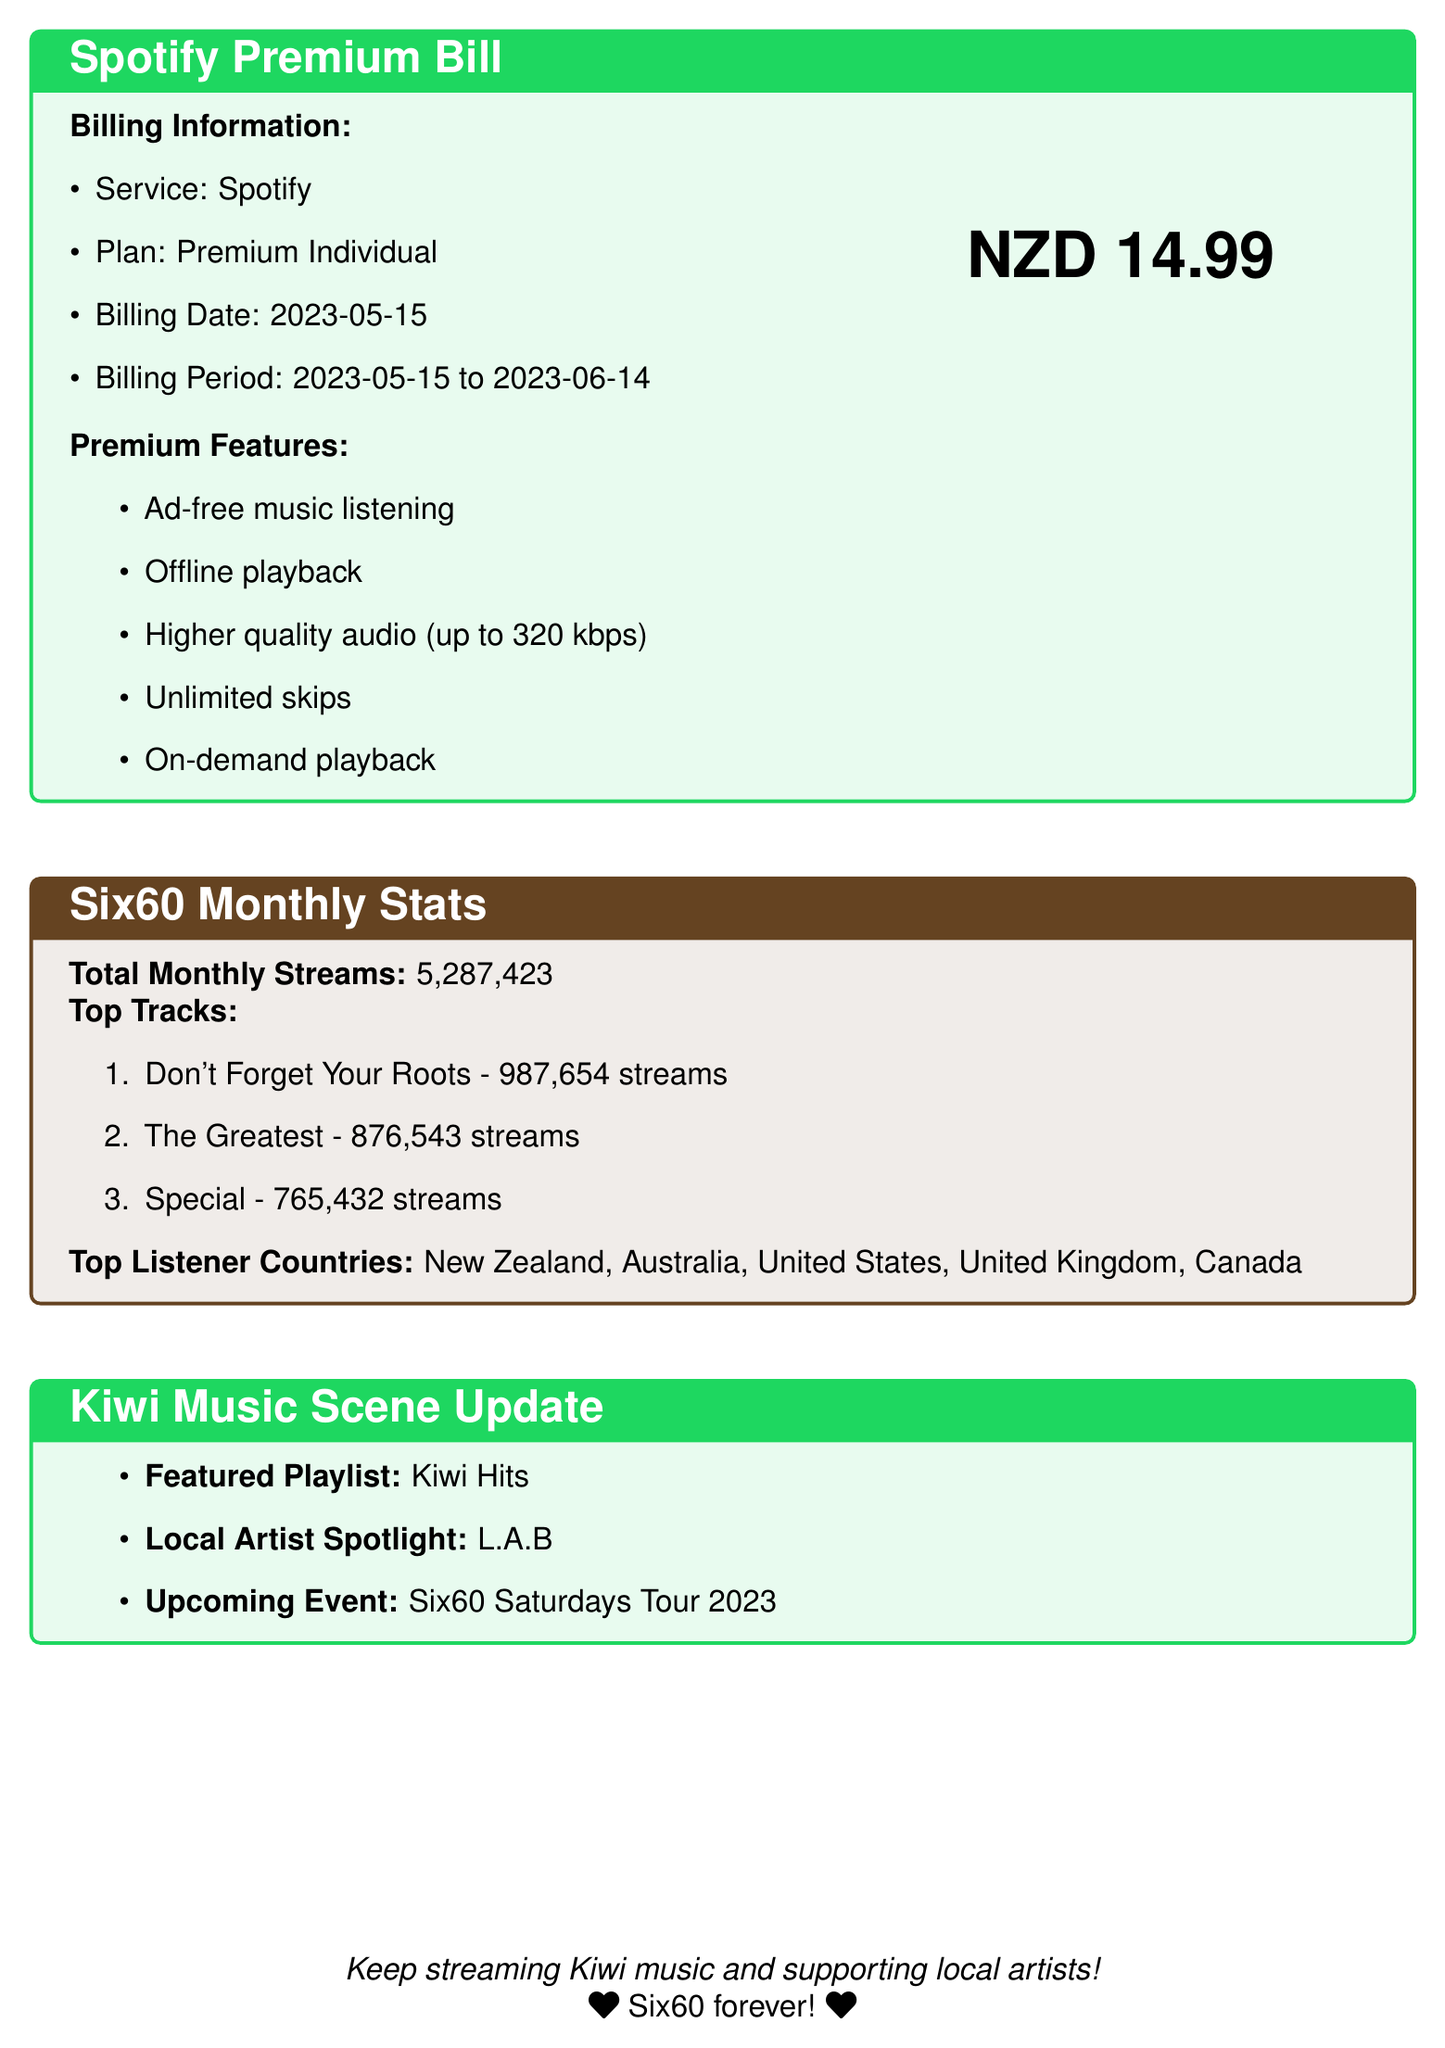What is the amount of the Spotify Premium bill? The amount charged for the premium bill is indicated in the document, which shows NZD 14.99.
Answer: NZD 14.99 What are the premium features included in the subscription? The document lists five premium features provided in the subscription service.
Answer: Ad-free music listening, Offline playback, Higher quality audio (up to 320 kbps), Unlimited skips, On-demand playback How many total monthly streams did Six60 have? The document specifies the total monthly streams for Six60, which is 5,287,423.
Answer: 5,287,423 Which track had the highest number of streams? The top track is named in the overview with the highest streams.
Answer: Don't Forget Your Roots How many streams did "The Greatest" track have? The document provides the streaming statistics for individual tracks, especially "The Greatest".
Answer: 876,543 streams What is the billing date for the Spotify Premium bill? The specific billing date is noted in the document.
Answer: 2023-05-15 Who is the local artist spotlighted in the Kiwi Music Scene update? The document highlights a feature about a local artist within the Kiwi music scene section.
Answer: L.A.B Which country is listed as one of the top listener countries? The document specifies countries where Six60's listeners are based, mentioning several names.
Answer: New Zealand What is the upcoming event related to Six60 mentioned in the bill? The document contains an upcoming event associated with Six60, indicated in the music scene update.
Answer: Six60 Saturdays Tour 2023 